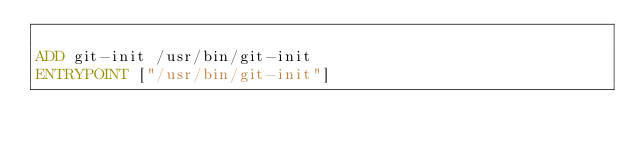<code> <loc_0><loc_0><loc_500><loc_500><_Dockerfile_>
ADD git-init /usr/bin/git-init
ENTRYPOINT ["/usr/bin/git-init"]
</code> 